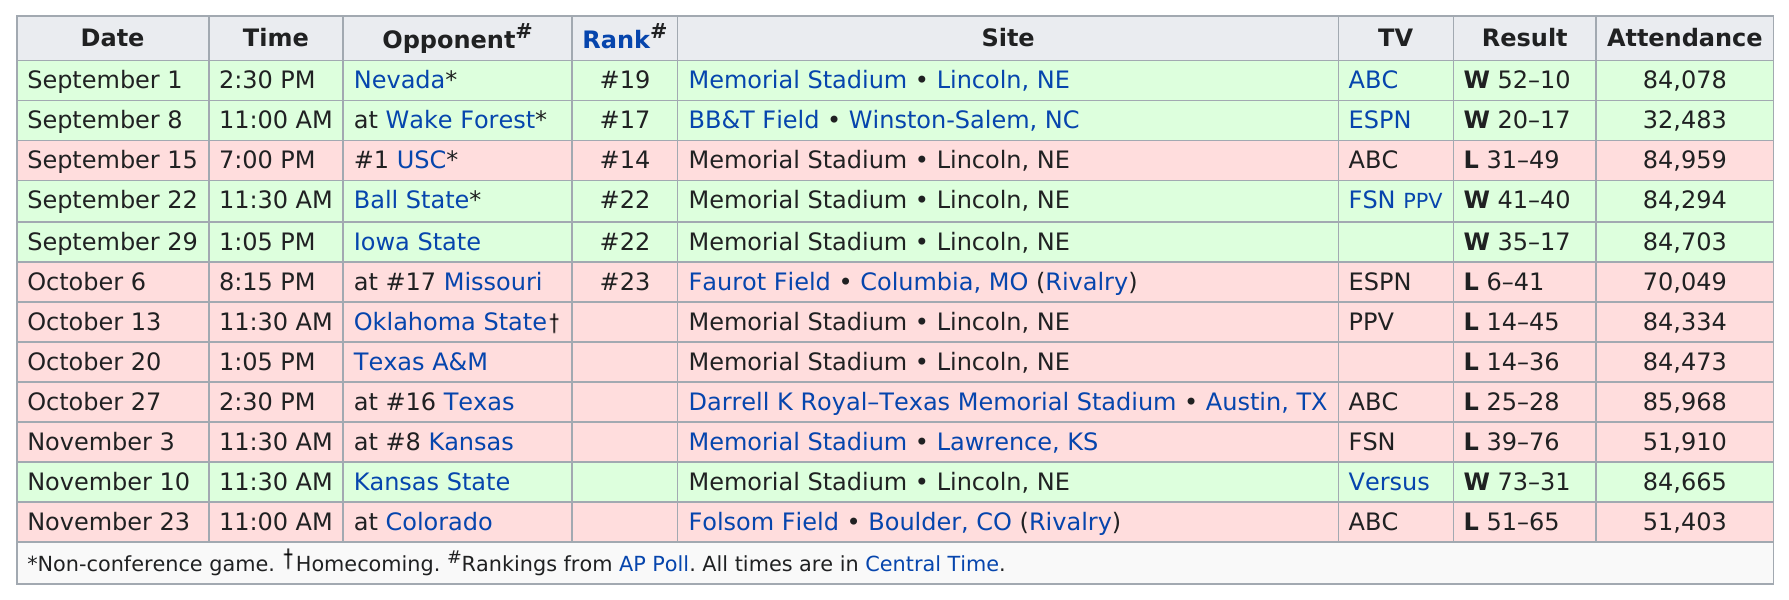Highlight a few significant elements in this photo. There are 6 sites. In 2007, the Nebraska football team won a record-breaking 13 consecutive games, cementing their status as one of the best teams in the country. In 2007, the total number of television networks that aired Nebraska football games was five. Wake Forest is the opponent that comes before USC in the list of upcoming games. During the 2007 season, the Nebraska Cornhuskers achieved their highest rank of 14. 